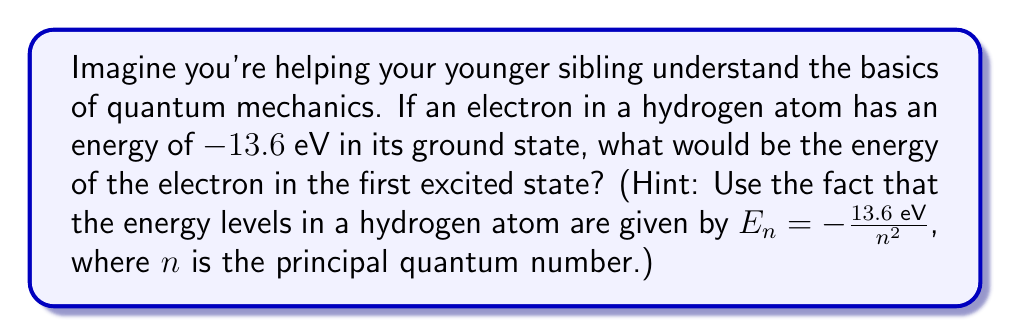Can you answer this question? Let's approach this step-by-step:

1) First, recall that in quantum mechanics, electrons in atoms can only exist in specific energy levels. These energy levels are described by the principal quantum number $n$.

2) For a hydrogen atom, the energy levels are given by the formula:

   $$E_n = -\frac{13.6 \text{ eV}}{n^2}$$

   where $E_n$ is the energy of the electron in the $n$th energy level.

3) The ground state corresponds to $n = 1$. We can verify this:

   $$E_1 = -\frac{13.6 \text{ eV}}{1^2} = -13.6 \text{ eV}$$

4) The first excited state corresponds to $n = 2$. Let's calculate this:

   $$E_2 = -\frac{13.6 \text{ eV}}{2^2} = -\frac{13.6 \text{ eV}}{4} = -3.4 \text{ eV}$$

5) Therefore, in the first excited state, the electron would have an energy of $-3.4$ eV.

This problem demonstrates how spectral theory relates to quantum mechanics. The discrete energy levels (spectrum) of the hydrogen atom are a direct result of solving the Schrödinger equation, which is a fundamental equation in quantum mechanics.
Answer: $-3.4$ eV 